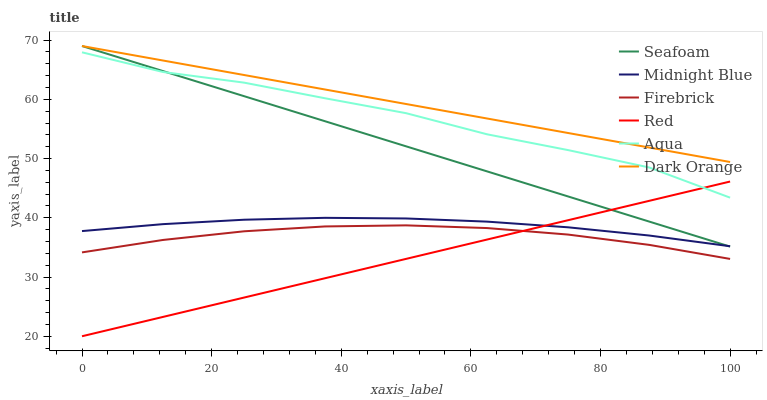Does Red have the minimum area under the curve?
Answer yes or no. Yes. Does Dark Orange have the maximum area under the curve?
Answer yes or no. Yes. Does Midnight Blue have the minimum area under the curve?
Answer yes or no. No. Does Midnight Blue have the maximum area under the curve?
Answer yes or no. No. Is Red the smoothest?
Answer yes or no. Yes. Is Aqua the roughest?
Answer yes or no. Yes. Is Midnight Blue the smoothest?
Answer yes or no. No. Is Midnight Blue the roughest?
Answer yes or no. No. Does Red have the lowest value?
Answer yes or no. Yes. Does Midnight Blue have the lowest value?
Answer yes or no. No. Does Seafoam have the highest value?
Answer yes or no. Yes. Does Midnight Blue have the highest value?
Answer yes or no. No. Is Red less than Dark Orange?
Answer yes or no. Yes. Is Dark Orange greater than Midnight Blue?
Answer yes or no. Yes. Does Midnight Blue intersect Red?
Answer yes or no. Yes. Is Midnight Blue less than Red?
Answer yes or no. No. Is Midnight Blue greater than Red?
Answer yes or no. No. Does Red intersect Dark Orange?
Answer yes or no. No. 